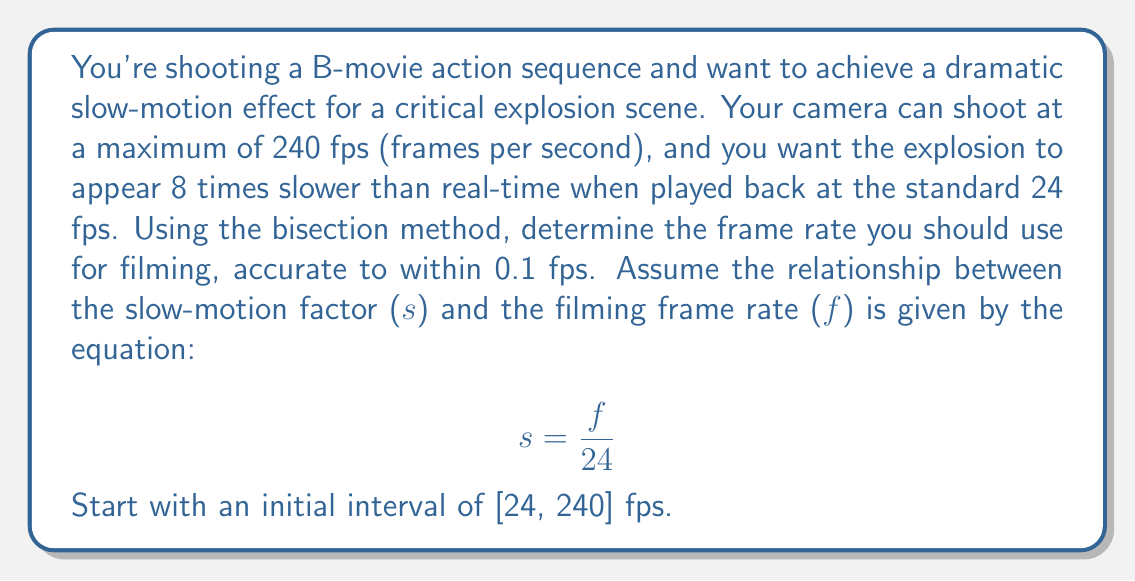Can you answer this question? To solve this problem, we'll use the bisection method to find the root of the equation:

$$ s - \frac{f}{24} = 0 $$

Where $s = 8$ (8 times slower than real-time) and $f$ is the frame rate we're looking for.

Let's define our function:

$$ g(f) = 8 - \frac{f}{24} $$

We need to find $f$ such that $g(f) = 0$.

Initial interval: $[a_0, b_0] = [24, 240]$

Step 1: Calculate midpoint and function values
$$ c_0 = \frac{a_0 + b_0}{2} = \frac{24 + 240}{2} = 132 $$
$$ g(a_0) = 8 - \frac{24}{24} = 7 > 0 $$
$$ g(b_0) = 8 - \frac{240}{24} = -2 < 0 $$
$$ g(c_0) = 8 - \frac{132}{24} = 2.5 > 0 $$

Since $g(c_0) > 0$, we update $a_1 = c_0 = 132$ and $b_1 = b_0 = 240$.

Step 2: Repeat the process
$$ c_1 = \frac{132 + 240}{2} = 186 $$
$$ g(c_1) = 8 - \frac{186}{24} = 0.25 > 0 $$

Update: $a_2 = 186$, $b_2 = 240$

Step 3:
$$ c_2 = \frac{186 + 240}{2} = 213 $$
$$ g(c_2) = 8 - \frac{213}{24} = -0.875 < 0 $$

Update: $a_3 = 186$, $b_3 = 213$

Step 4:
$$ c_3 = \frac{186 + 213}{2} = 199.5 $$
$$ g(c_3) = 8 - \frac{199.5}{24} = -0.3125 < 0 $$

Update: $a_4 = 186$, $b_4 = 199.5$

Step 5:
$$ c_4 = \frac{186 + 199.5}{2} = 192.75 $$
$$ g(c_4) = 8 - \frac{192.75}{24} = -0.03125 < 0 $$

Update: $a_5 = 186$, $b_5 = 192.75$

The difference between $a_5$ and $b_5$ is 6.75 fps, which is greater than our desired accuracy of 0.1 fps. We need one more iteration.

Step 6:
$$ c_5 = \frac{186 + 192.75}{2} = 189.375 $$
$$ g(c_5) = 8 - \frac{189.375}{24} = 0.109375 > 0 $$

Update: $a_6 = 189.375$, $b_6 = 192.75$

The difference between $a_6$ and $b_6$ is 3.375 fps, which is still greater than 0.1 fps. However, we can see that the root lies between 189.375 and 192.75 fps.

Since we're asked for accuracy within 0.1 fps, we can report the midpoint of this final interval as our answer.
Answer: $$ f \approx \frac{189.375 + 192.75}{2} = 191.0625 \text{ fps} $$

Rounding to the nearest tenth: 191.1 fps 